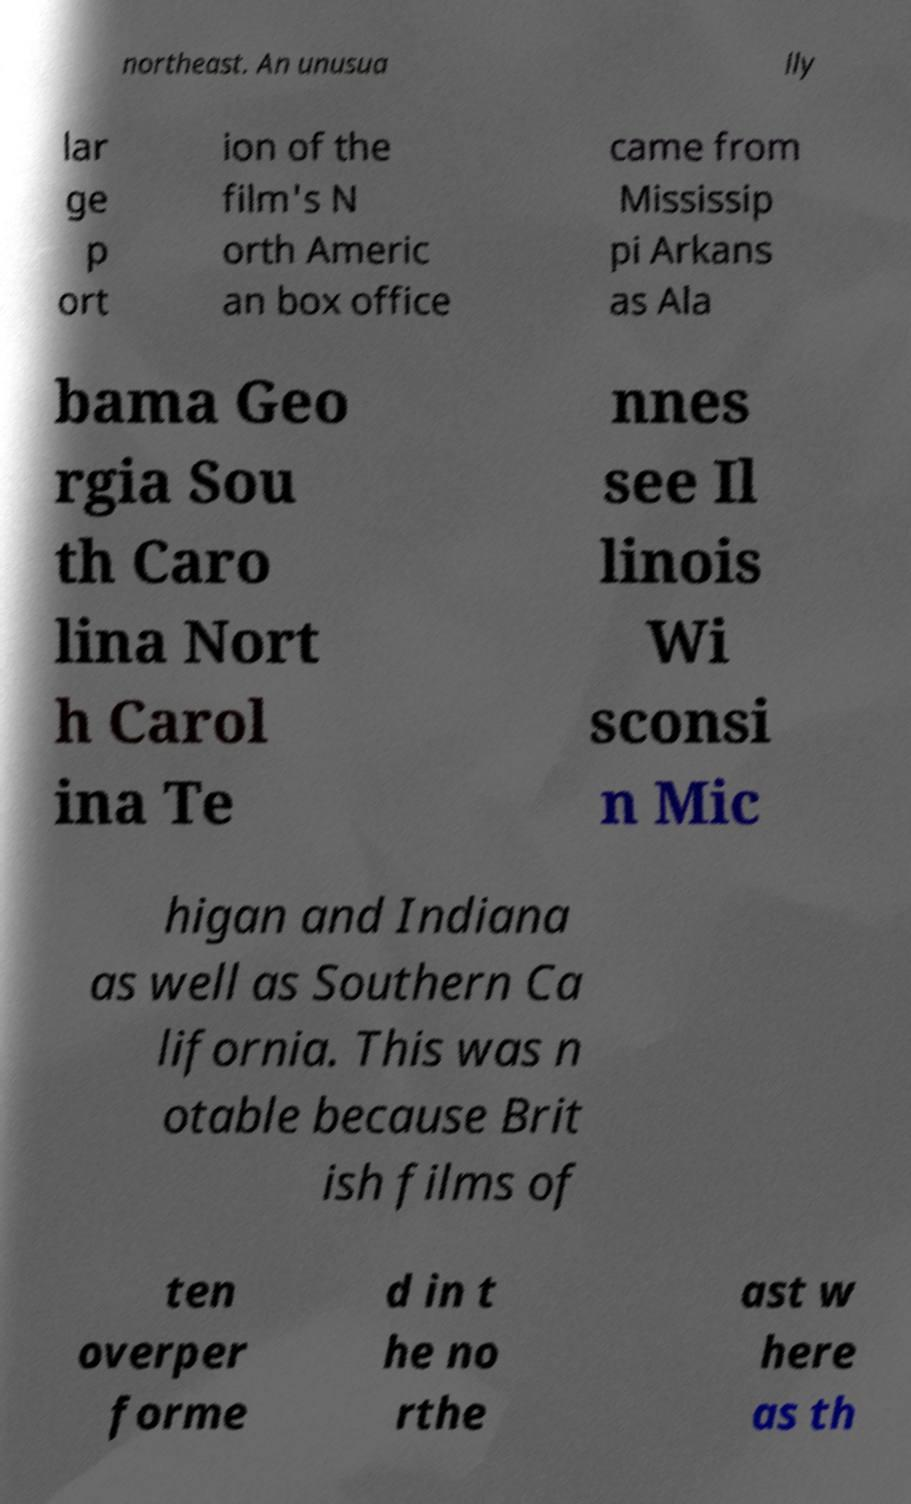There's text embedded in this image that I need extracted. Can you transcribe it verbatim? northeast. An unusua lly lar ge p ort ion of the film's N orth Americ an box office came from Mississip pi Arkans as Ala bama Geo rgia Sou th Caro lina Nort h Carol ina Te nnes see Il linois Wi sconsi n Mic higan and Indiana as well as Southern Ca lifornia. This was n otable because Brit ish films of ten overper forme d in t he no rthe ast w here as th 